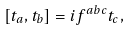Convert formula to latex. <formula><loc_0><loc_0><loc_500><loc_500>[ t _ { a } , t _ { b } ] = i f ^ { a b c } t _ { c } ,</formula> 